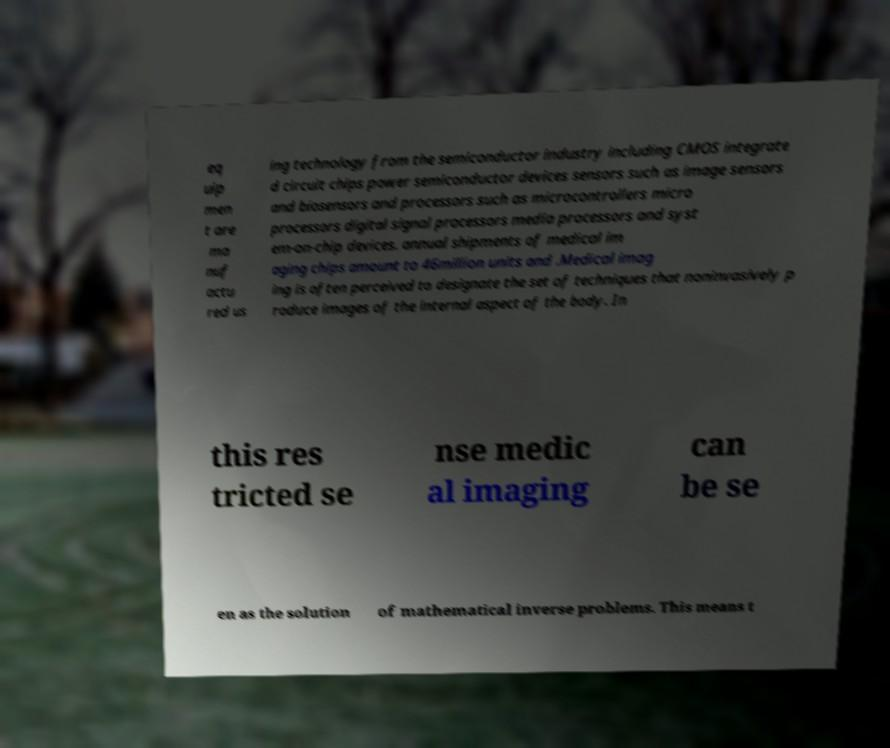Please read and relay the text visible in this image. What does it say? eq uip men t are ma nuf actu red us ing technology from the semiconductor industry including CMOS integrate d circuit chips power semiconductor devices sensors such as image sensors and biosensors and processors such as microcontrollers micro processors digital signal processors media processors and syst em-on-chip devices. annual shipments of medical im aging chips amount to 46million units and .Medical imag ing is often perceived to designate the set of techniques that noninvasively p roduce images of the internal aspect of the body. In this res tricted se nse medic al imaging can be se en as the solution of mathematical inverse problems. This means t 